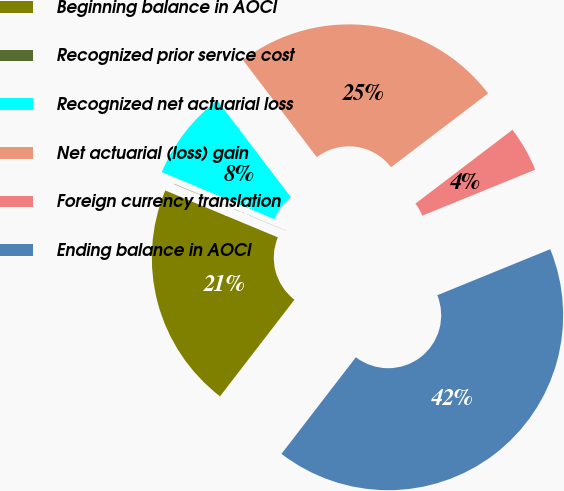<chart> <loc_0><loc_0><loc_500><loc_500><pie_chart><fcel>Beginning balance in AOCI<fcel>Recognized prior service cost<fcel>Recognized net actuarial loss<fcel>Net actuarial (loss) gain<fcel>Foreign currency translation<fcel>Ending balance in AOCI<nl><fcel>20.84%<fcel>0.03%<fcel>8.34%<fcel>25.0%<fcel>4.19%<fcel>41.61%<nl></chart> 